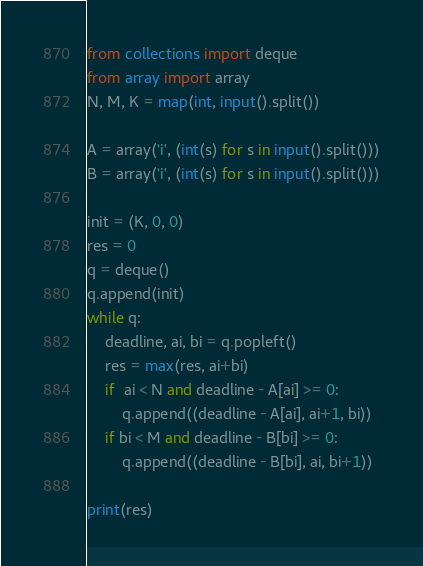<code> <loc_0><loc_0><loc_500><loc_500><_Python_>from collections import deque
from array import array
N, M, K = map(int, input().split())

A = array('i', (int(s) for s in input().split()))
B = array('i', (int(s) for s in input().split()))

init = (K, 0, 0)
res = 0
q = deque()
q.append(init)
while q:
    deadline, ai, bi = q.popleft()
    res = max(res, ai+bi)
    if  ai < N and deadline - A[ai] >= 0:
        q.append((deadline - A[ai], ai+1, bi))
    if bi < M and deadline - B[bi] >= 0:
        q.append((deadline - B[bi], ai, bi+1))
    
print(res)
</code> 